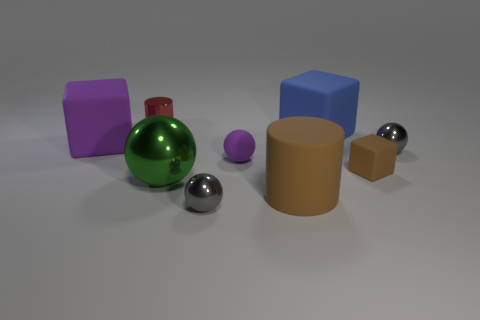Subtract all green balls. How many balls are left? 3 Subtract all red cylinders. How many cylinders are left? 1 Subtract 2 blocks. How many blocks are left? 1 Add 2 big spheres. How many big spheres are left? 3 Add 1 big cyan objects. How many big cyan objects exist? 1 Subtract 0 yellow spheres. How many objects are left? 9 Subtract all blocks. How many objects are left? 6 Subtract all yellow cylinders. Subtract all yellow balls. How many cylinders are left? 2 Subtract all blue blocks. How many gray balls are left? 2 Subtract all red things. Subtract all large yellow shiny cylinders. How many objects are left? 8 